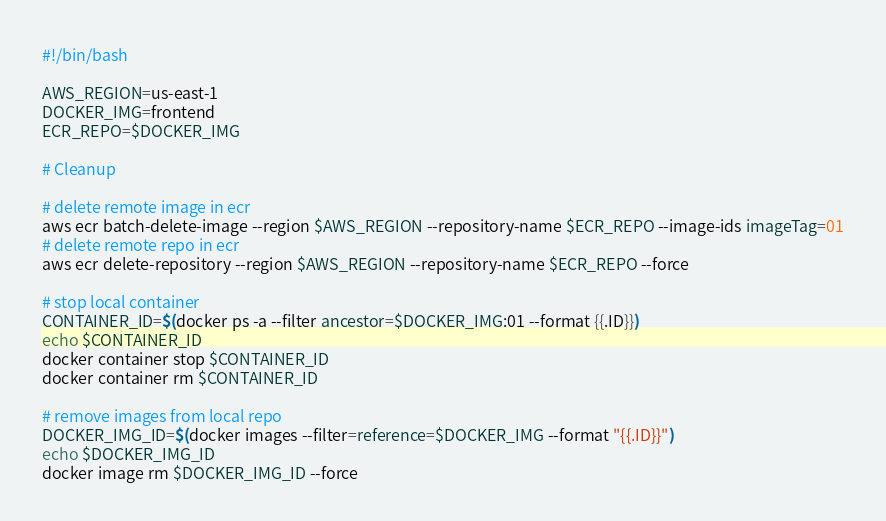Convert code to text. <code><loc_0><loc_0><loc_500><loc_500><_Bash_>#!/bin/bash

AWS_REGION=us-east-1
DOCKER_IMG=frontend
ECR_REPO=$DOCKER_IMG

# Cleanup

# delete remote image in ecr
aws ecr batch-delete-image --region $AWS_REGION --repository-name $ECR_REPO --image-ids imageTag=01
# delete remote repo in ecr
aws ecr delete-repository --region $AWS_REGION --repository-name $ECR_REPO --force

# stop local container
CONTAINER_ID=$(docker ps -a --filter ancestor=$DOCKER_IMG:01 --format {{.ID}})
echo $CONTAINER_ID
docker container stop $CONTAINER_ID
docker container rm $CONTAINER_ID

# remove images from local repo
DOCKER_IMG_ID=$(docker images --filter=reference=$DOCKER_IMG --format "{{.ID}}")
echo $DOCKER_IMG_ID
docker image rm $DOCKER_IMG_ID --force

</code> 